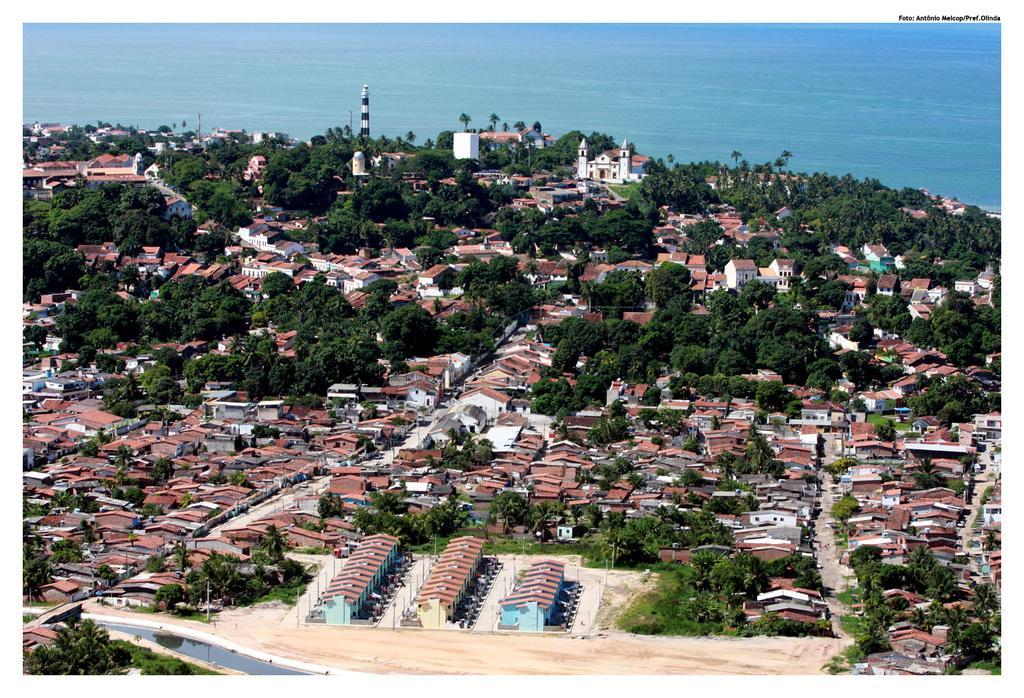In one or two sentences, can you explain what this image depicts? In this picture I can see buildings, trees and I can see a tower and water in the background and I can see text on the top right corner and water at the bottom left corner of the picture. 